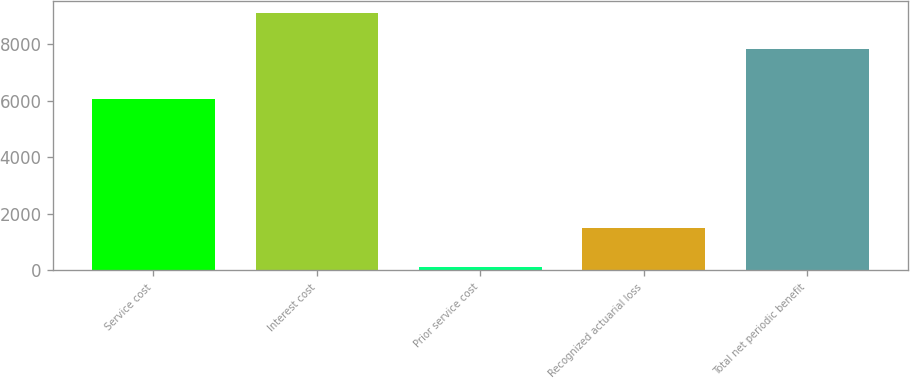Convert chart to OTSL. <chart><loc_0><loc_0><loc_500><loc_500><bar_chart><fcel>Service cost<fcel>Interest cost<fcel>Prior service cost<fcel>Recognized actuarial loss<fcel>Total net periodic benefit<nl><fcel>6043<fcel>9081<fcel>114<fcel>1492<fcel>7810<nl></chart> 